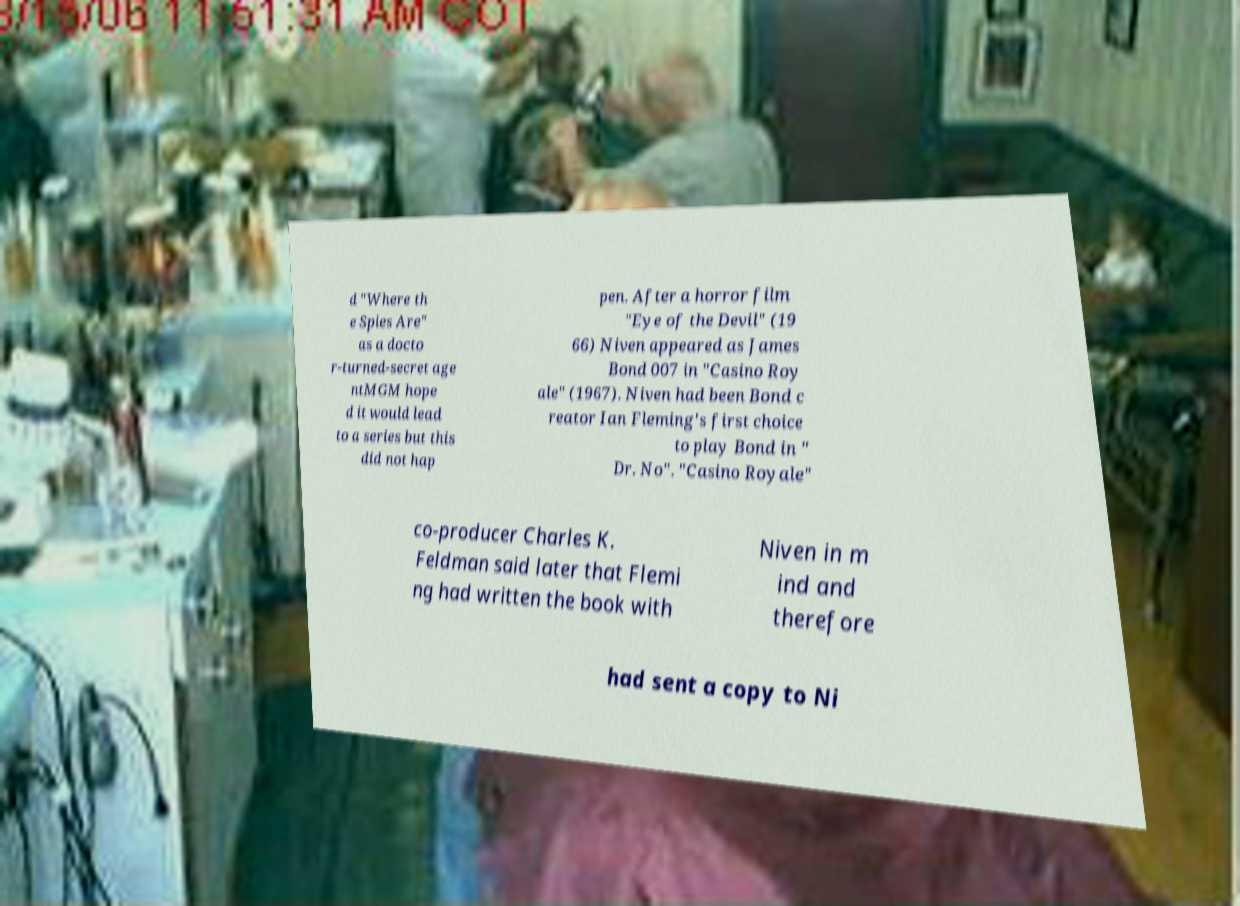What messages or text are displayed in this image? I need them in a readable, typed format. d "Where th e Spies Are" as a docto r-turned-secret age ntMGM hope d it would lead to a series but this did not hap pen. After a horror film "Eye of the Devil" (19 66) Niven appeared as James Bond 007 in "Casino Roy ale" (1967). Niven had been Bond c reator Ian Fleming's first choice to play Bond in " Dr. No". "Casino Royale" co-producer Charles K. Feldman said later that Flemi ng had written the book with Niven in m ind and therefore had sent a copy to Ni 